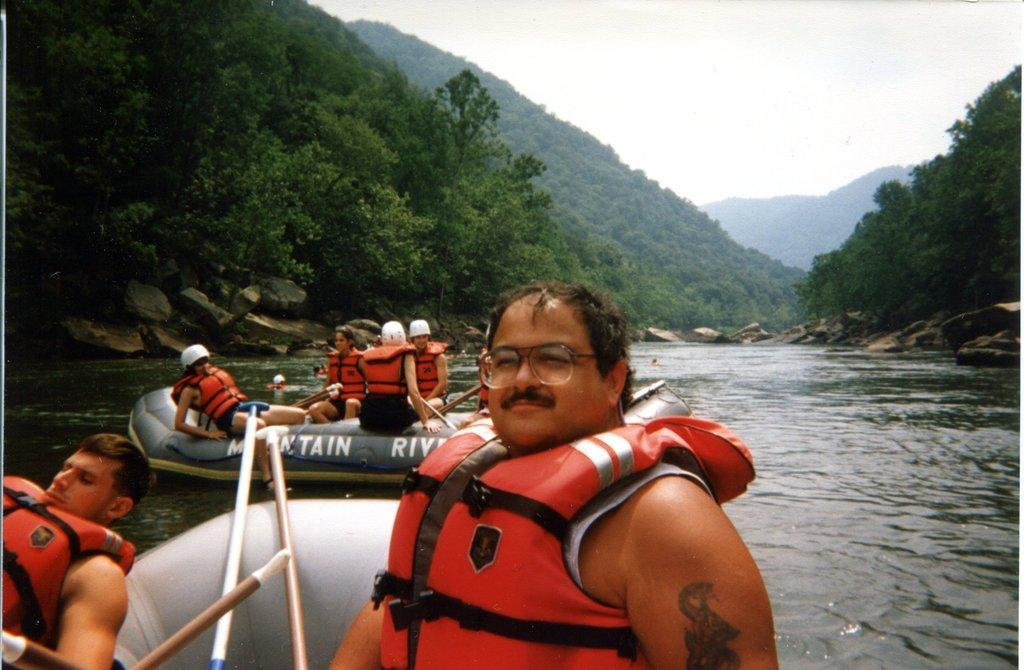What are the people doing in the image? The people are in a boat in the image. What body of water is visible in the image? There is a lake in the image. What type of landscape can be seen in the background of the image? There are mountains covered with trees in the image. What is the condition of the sky in the image? The sky is clear in the image. Can you tell me how many owls are sitting on the boat in the image? There are no owls present in the image; it features people in a boat on a lake with mountains and a clear sky. What type of drink is being served on the boat in the image? There is no drink visible in the image; it only shows people in a boat on a lake with mountains and a clear sky. 